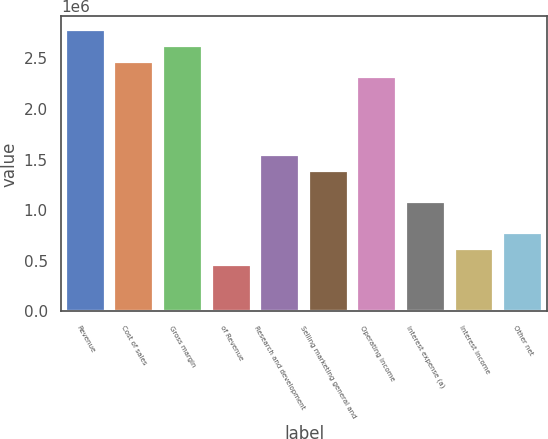Convert chart. <chart><loc_0><loc_0><loc_500><loc_500><bar_chart><fcel>Revenue<fcel>Cost of sales<fcel>Gross margin<fcel>of Revenue<fcel>Research and development<fcel>Selling marketing general and<fcel>Operating income<fcel>Interest expense (a)<fcel>Interest income<fcel>Other net<nl><fcel>2.77411e+06<fcel>2.46587e+06<fcel>2.61999e+06<fcel>462351<fcel>1.54117e+06<fcel>1.38705e+06<fcel>2.31175e+06<fcel>1.07882e+06<fcel>616468<fcel>770585<nl></chart> 